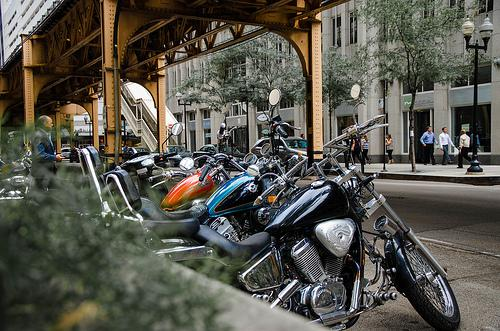Question: what are parked on the side of the street?
Choices:
A. Antique cars.
B. School buses.
C. Motorcycles.
D. Two semi trucks.
Answer with the letter. Answer: C Question: what are the men in the background doing?
Choices:
A. Running.
B. Walking.
C. Jogging.
D. Exercising.
Answer with the letter. Answer: B Question: what color is the closest motorcycle?
Choices:
A. Red.
B. White.
C. Black.
D. Blue.
Answer with the letter. Answer: C Question: what dots the sidewalk?
Choices:
A. Red paint.
B. Trees.
C. Pebbles.
D. Chalk.
Answer with the letter. Answer: B Question: how many motorcycles are pictured?
Choices:
A. Six.
B. None.
C. Three.
D. Two.
Answer with the letter. Answer: A 